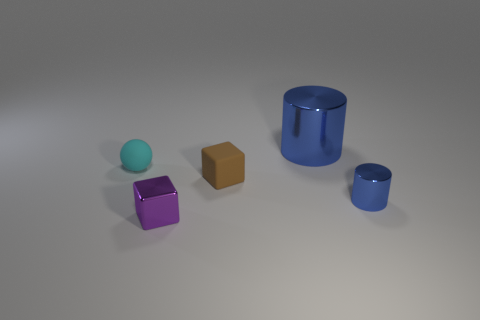What size is the metal object that is to the left of the tiny blue cylinder and behind the small purple shiny object?
Your answer should be very brief. Large. Are there any brown shiny cylinders of the same size as the matte block?
Your answer should be compact. No. There is a blue object that is the same size as the cyan sphere; what is it made of?
Keep it short and to the point. Metal. What number of objects are either objects that are on the right side of the small cyan rubber thing or blue shiny things that are in front of the small ball?
Offer a terse response. 4. Are there any other blue objects of the same shape as the large thing?
Provide a succinct answer. Yes. There is a big cylinder that is the same color as the small cylinder; what material is it?
Keep it short and to the point. Metal. What number of metal objects are either purple objects or tiny green things?
Offer a very short reply. 1. What is the shape of the big blue metallic object?
Provide a succinct answer. Cylinder. How many big blue cylinders are the same material as the cyan sphere?
Provide a succinct answer. 0. There is a small cylinder that is made of the same material as the large cylinder; what color is it?
Give a very brief answer. Blue. 